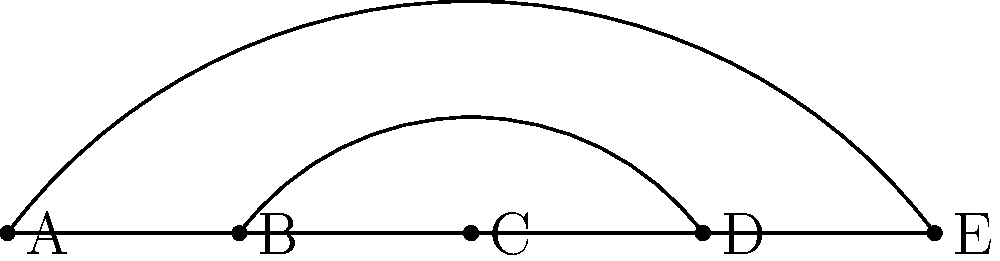Identify the network topology represented in the diagram above. Which type of topology allows for redundancy and multiple data paths between nodes? To identify the network topology and understand its benefits, let's follow these steps:

1. Observe the arrangement of nodes:
   - There are 5 nodes (A, B, C, D, E) arranged in a linear fashion.

2. Analyze the connections:
   - There's a direct line connecting all nodes (A-B-C-D-E).
   - There's an arc connecting A-C-E.
   - There's another arc connecting B-D.

3. Identify the topology:
   - This arrangement represents a Mesh topology, specifically a Partial Mesh.
   - In a full mesh, every node would be connected to every other node.

4. Understand the benefits:
   - Mesh topologies allow for multiple data paths between nodes.
   - If one path fails, data can be routed through alternative paths.
   - This creates redundancy in the network.

5. Compare to other topologies:
   - Bus: Single line, no redundancy.
   - Star: Central node, no direct node-to-node connections.
   - Ring: Circular connection, limited redundancy.

Therefore, the Mesh topology allows for redundancy and multiple data paths between nodes, making it more resilient to failures compared to other topologies.
Answer: Mesh topology 